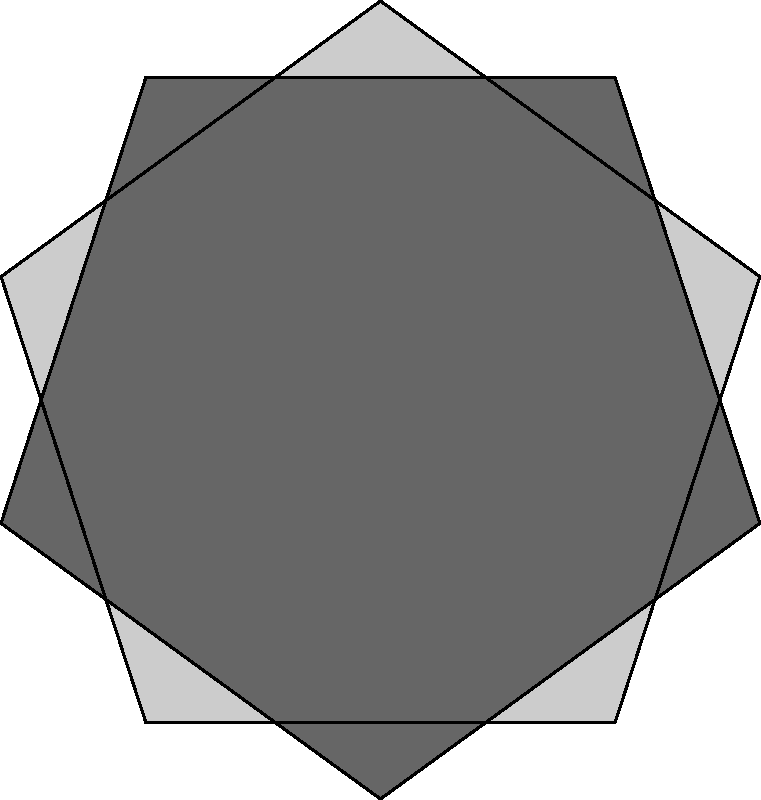In the context of information retrieval and pattern recognition, analyze the given geometric figure. How many complete pentagons can be identified within this complex overlapping structure? To solve this problem, we need to systematically analyze the geometric pattern:

1. First, observe the overall structure. The figure consists of three overlapping regular pentagons.

2. Identify the clearly visible pentagons:
   a. The light gray pentagon in the foreground
   b. The medium gray pentagon rotated clockwise
   c. The dark gray pentagon rotated counterclockwise

3. Look for additional pentagons formed by the intersections:
   d. A small pentagon is formed at the center where all three original pentagons overlap
   e. Five more small pentagons are formed around the central pentagon, each created by the intersection of two of the original pentagons

4. Count the total number of complete pentagons:
   3 (original large pentagons) + 1 (central small pentagon) + 5 (surrounding small pentagons) = 9

This analysis demonstrates the importance of systematic observation and pattern recognition in information retrieval, particularly when dealing with complex visual data structures.
Answer: 9 pentagons 